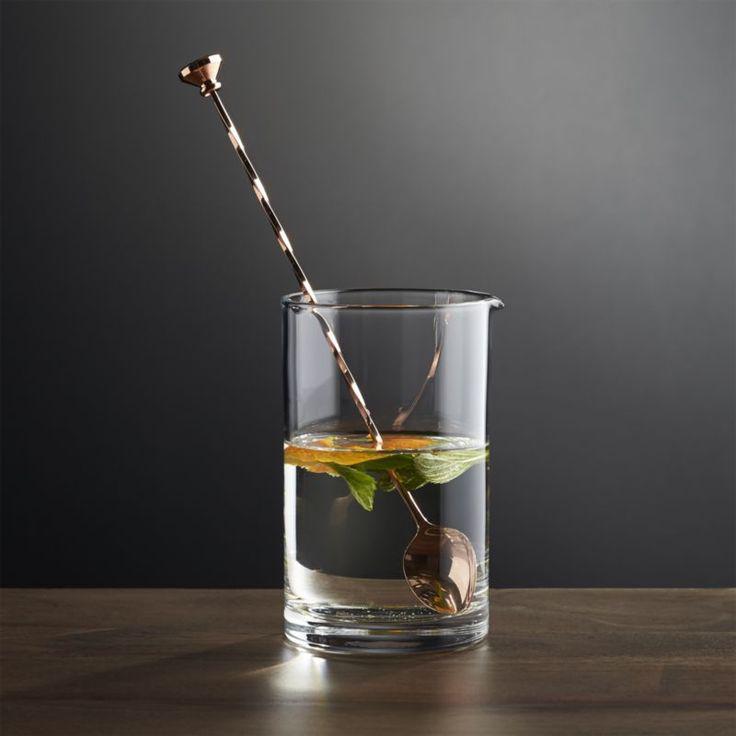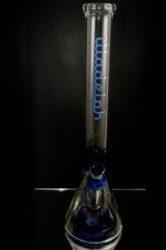The first image is the image on the left, the second image is the image on the right. Examine the images to the left and right. Is the description "The left image shows a cylindrical glass with liquid and a stirring spoon inside." accurate? Answer yes or no. Yes. 